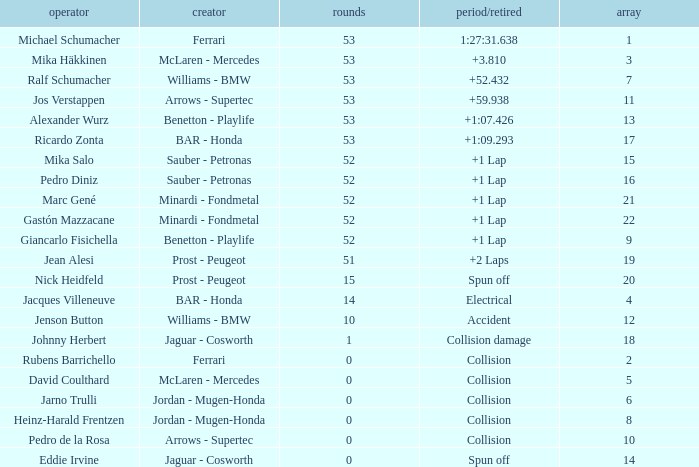What is the name of the driver with a grid less than 14, laps smaller than 53 and a Time/Retired of collision, and a Constructor of ferrari? Rubens Barrichello. 